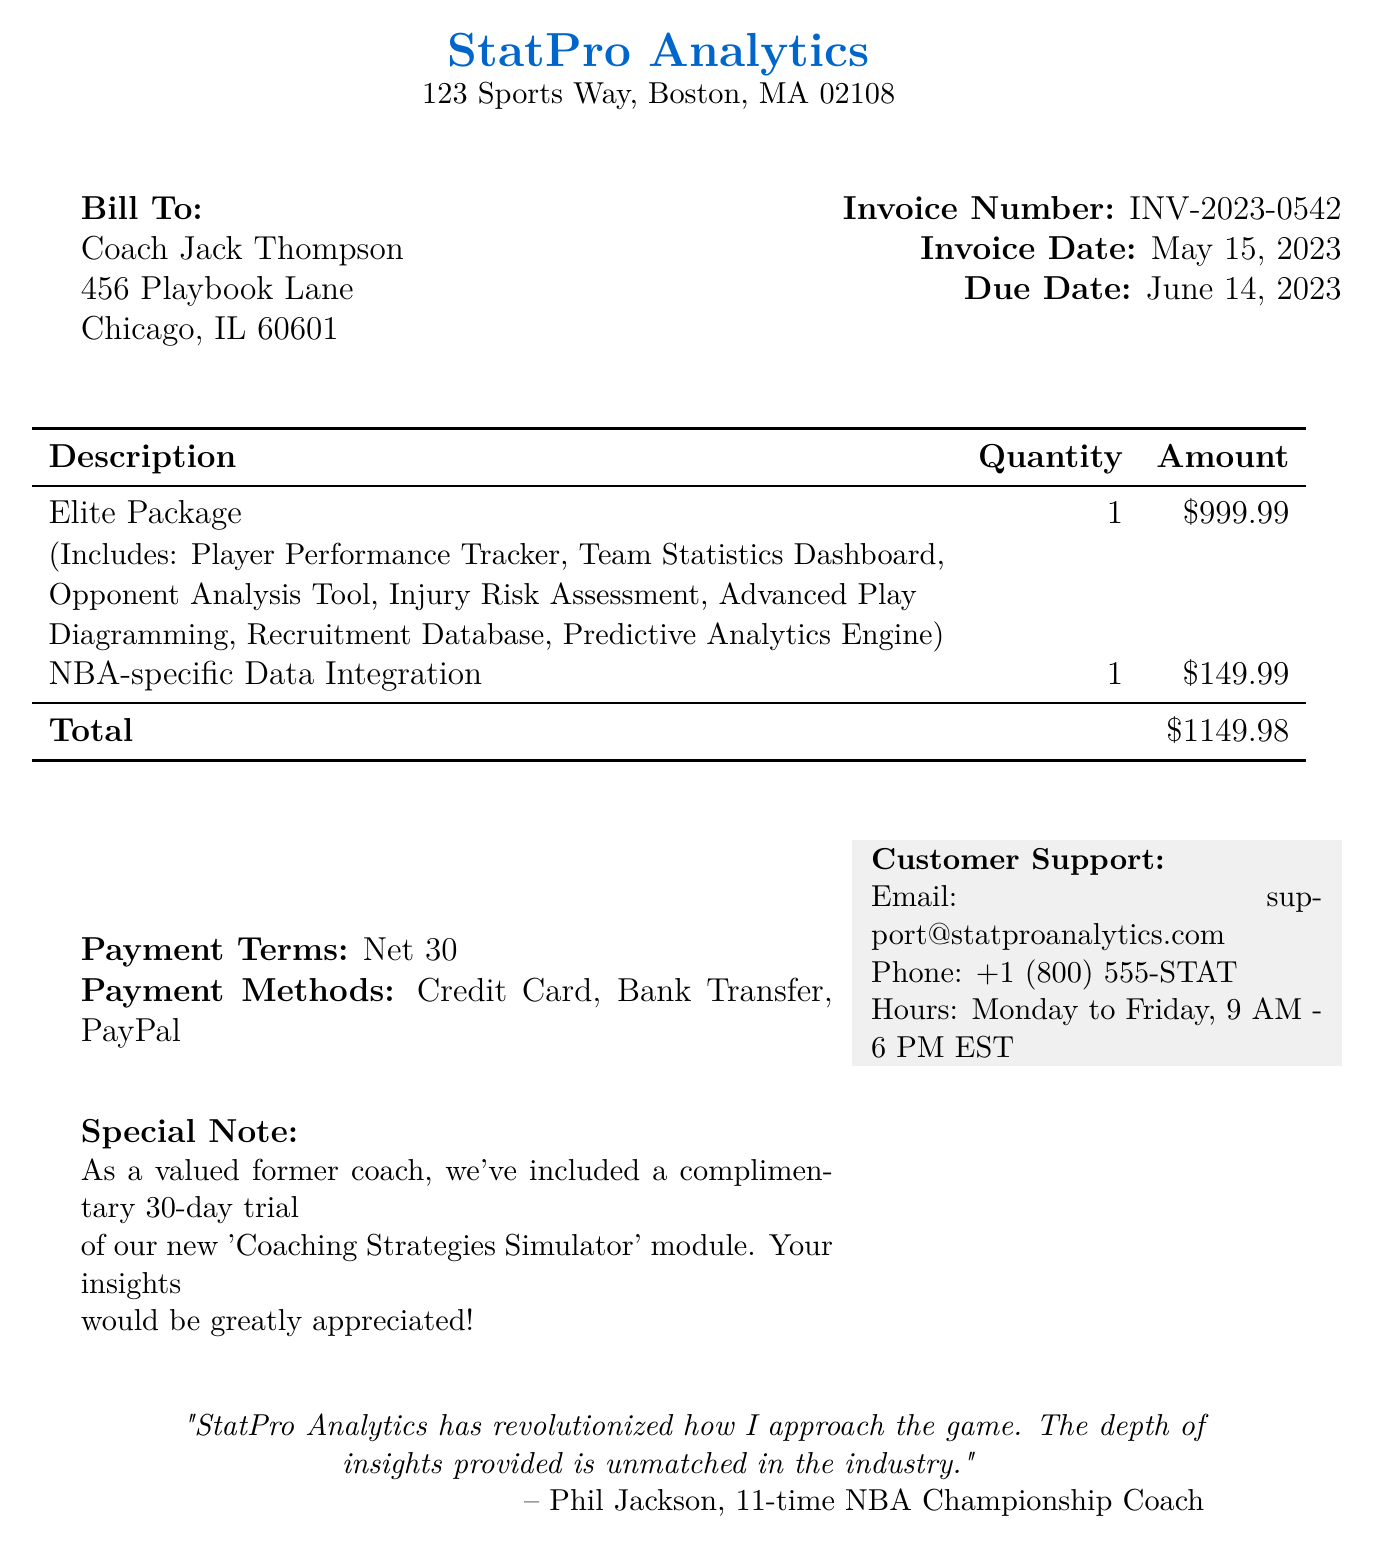What is the company name? The company name is provided at the top of the document as part of the header information.
Answer: StatPro Analytics What is the invoice number? The invoice number can be found in the invoice details section of the document.
Answer: INV-2023-0542 What is the total price? The total price is calculated based on the selected subscription tier and add-ons listed in the document.
Answer: 1149.98 What is included in the Elite Package? The included modules for the Elite Package are mentioned in the description under the Elite Package line entry.
Answer: Player Performance Tracker, Team Statistics Dashboard, Opponent Analysis Tool, Injury Risk Assessment, Advanced Play Diagramming, Recruitment Database, Predictive Analytics Engine What are the payment methods? The document lists different ways the customer can pay, which is typically found in the payment information section.
Answer: Credit Card, Bank Transfer, PayPal What is the due date for the invoice? The due date is specified in the invoice details section and reflects the timeline for payment.
Answer: June 14, 2023 What special note is included for Coach Jack Thompson? The special note provides additional value that was offered to the customer based on their status mentioned in the document.
Answer: Complimentary 30-day trial of our new 'Coaching Strategies Simulator' module What are the office hours for customer support? The office hours for customer support are displayed along with the contact information in the document.
Answer: Monday to Friday, 9 AM - 6 PM EST Who provided the testimonial in the document? The testimonial section includes a quote from a notable individual, which is found in the footer of the document.
Answer: Phil Jackson, 11-time NBA Championship Coach 